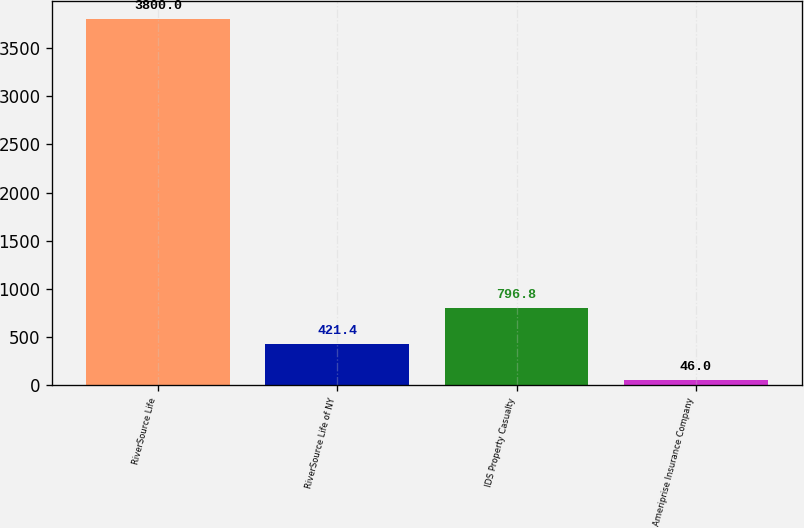<chart> <loc_0><loc_0><loc_500><loc_500><bar_chart><fcel>RiverSource Life<fcel>RiverSource Life of NY<fcel>IDS Property Casualty<fcel>Ameriprise Insurance Company<nl><fcel>3800<fcel>421.4<fcel>796.8<fcel>46<nl></chart> 